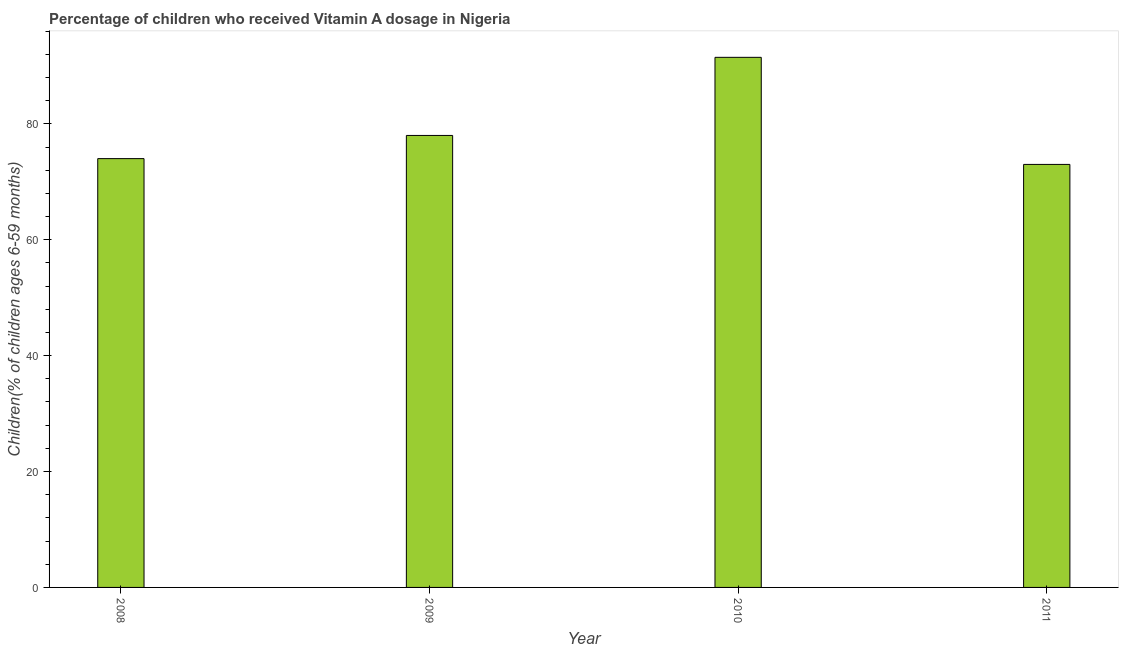Does the graph contain grids?
Your response must be concise. No. What is the title of the graph?
Offer a terse response. Percentage of children who received Vitamin A dosage in Nigeria. What is the label or title of the X-axis?
Offer a very short reply. Year. What is the label or title of the Y-axis?
Keep it short and to the point. Children(% of children ages 6-59 months). Across all years, what is the maximum vitamin a supplementation coverage rate?
Ensure brevity in your answer.  91.48. In which year was the vitamin a supplementation coverage rate minimum?
Ensure brevity in your answer.  2011. What is the sum of the vitamin a supplementation coverage rate?
Your answer should be compact. 316.48. What is the difference between the vitamin a supplementation coverage rate in 2008 and 2011?
Give a very brief answer. 1. What is the average vitamin a supplementation coverage rate per year?
Provide a short and direct response. 79.12. In how many years, is the vitamin a supplementation coverage rate greater than 88 %?
Ensure brevity in your answer.  1. Do a majority of the years between 2009 and 2010 (inclusive) have vitamin a supplementation coverage rate greater than 80 %?
Provide a short and direct response. No. What is the ratio of the vitamin a supplementation coverage rate in 2009 to that in 2011?
Your response must be concise. 1.07. Is the vitamin a supplementation coverage rate in 2009 less than that in 2011?
Offer a very short reply. No. What is the difference between the highest and the second highest vitamin a supplementation coverage rate?
Offer a terse response. 13.48. Is the sum of the vitamin a supplementation coverage rate in 2008 and 2011 greater than the maximum vitamin a supplementation coverage rate across all years?
Provide a succinct answer. Yes. What is the difference between the highest and the lowest vitamin a supplementation coverage rate?
Make the answer very short. 18.48. How many bars are there?
Keep it short and to the point. 4. Are all the bars in the graph horizontal?
Your answer should be compact. No. What is the Children(% of children ages 6-59 months) in 2009?
Provide a short and direct response. 78. What is the Children(% of children ages 6-59 months) in 2010?
Your answer should be very brief. 91.48. What is the difference between the Children(% of children ages 6-59 months) in 2008 and 2009?
Give a very brief answer. -4. What is the difference between the Children(% of children ages 6-59 months) in 2008 and 2010?
Provide a succinct answer. -17.48. What is the difference between the Children(% of children ages 6-59 months) in 2009 and 2010?
Provide a succinct answer. -13.48. What is the difference between the Children(% of children ages 6-59 months) in 2010 and 2011?
Ensure brevity in your answer.  18.48. What is the ratio of the Children(% of children ages 6-59 months) in 2008 to that in 2009?
Provide a short and direct response. 0.95. What is the ratio of the Children(% of children ages 6-59 months) in 2008 to that in 2010?
Offer a very short reply. 0.81. What is the ratio of the Children(% of children ages 6-59 months) in 2009 to that in 2010?
Make the answer very short. 0.85. What is the ratio of the Children(% of children ages 6-59 months) in 2009 to that in 2011?
Keep it short and to the point. 1.07. What is the ratio of the Children(% of children ages 6-59 months) in 2010 to that in 2011?
Your answer should be very brief. 1.25. 